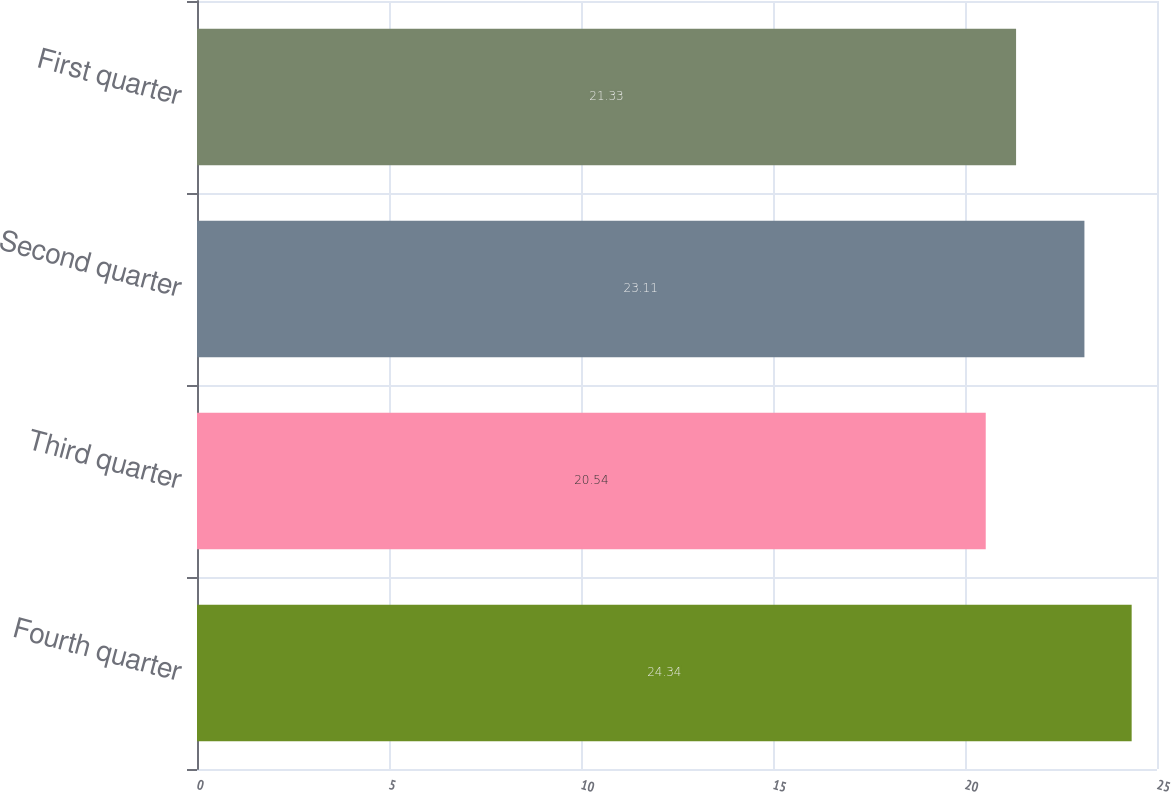Convert chart. <chart><loc_0><loc_0><loc_500><loc_500><bar_chart><fcel>Fourth quarter<fcel>Third quarter<fcel>Second quarter<fcel>First quarter<nl><fcel>24.34<fcel>20.54<fcel>23.11<fcel>21.33<nl></chart> 